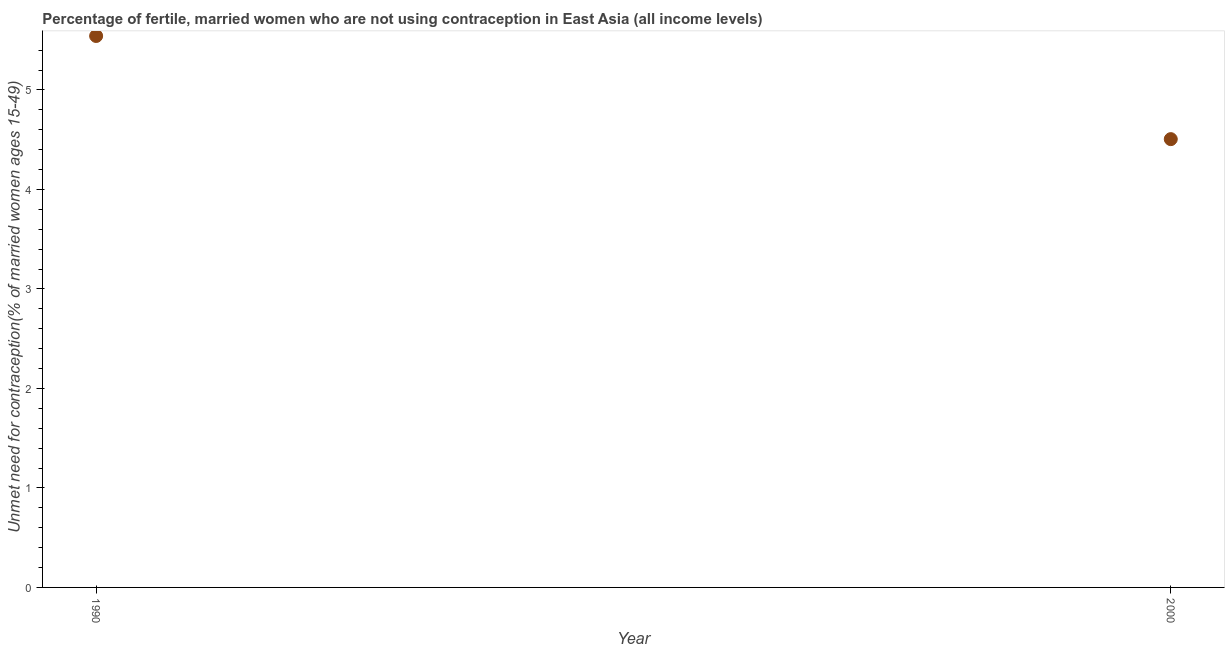What is the number of married women who are not using contraception in 2000?
Provide a short and direct response. 4.51. Across all years, what is the maximum number of married women who are not using contraception?
Offer a terse response. 5.54. Across all years, what is the minimum number of married women who are not using contraception?
Your response must be concise. 4.51. In which year was the number of married women who are not using contraception maximum?
Your answer should be compact. 1990. In which year was the number of married women who are not using contraception minimum?
Provide a succinct answer. 2000. What is the sum of the number of married women who are not using contraception?
Your answer should be compact. 10.05. What is the difference between the number of married women who are not using contraception in 1990 and 2000?
Your answer should be compact. 1.04. What is the average number of married women who are not using contraception per year?
Provide a short and direct response. 5.02. What is the median number of married women who are not using contraception?
Give a very brief answer. 5.02. In how many years, is the number of married women who are not using contraception greater than 1.2 %?
Offer a terse response. 2. What is the ratio of the number of married women who are not using contraception in 1990 to that in 2000?
Offer a terse response. 1.23. Is the number of married women who are not using contraception in 1990 less than that in 2000?
Provide a short and direct response. No. In how many years, is the number of married women who are not using contraception greater than the average number of married women who are not using contraception taken over all years?
Keep it short and to the point. 1. Does the number of married women who are not using contraception monotonically increase over the years?
Offer a terse response. No. How many years are there in the graph?
Your answer should be compact. 2. Are the values on the major ticks of Y-axis written in scientific E-notation?
Provide a short and direct response. No. Does the graph contain any zero values?
Keep it short and to the point. No. What is the title of the graph?
Offer a terse response. Percentage of fertile, married women who are not using contraception in East Asia (all income levels). What is the label or title of the Y-axis?
Give a very brief answer.  Unmet need for contraception(% of married women ages 15-49). What is the  Unmet need for contraception(% of married women ages 15-49) in 1990?
Make the answer very short. 5.54. What is the  Unmet need for contraception(% of married women ages 15-49) in 2000?
Your answer should be compact. 4.51. What is the difference between the  Unmet need for contraception(% of married women ages 15-49) in 1990 and 2000?
Offer a very short reply. 1.04. What is the ratio of the  Unmet need for contraception(% of married women ages 15-49) in 1990 to that in 2000?
Keep it short and to the point. 1.23. 